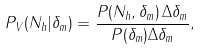Convert formula to latex. <formula><loc_0><loc_0><loc_500><loc_500>P _ { V } ( N _ { h } | \delta _ { m } ) = \frac { P ( N _ { h } , \delta _ { m } ) \, \Delta \delta _ { m } } { P ( \delta _ { m } ) \Delta \delta _ { m } } ,</formula> 